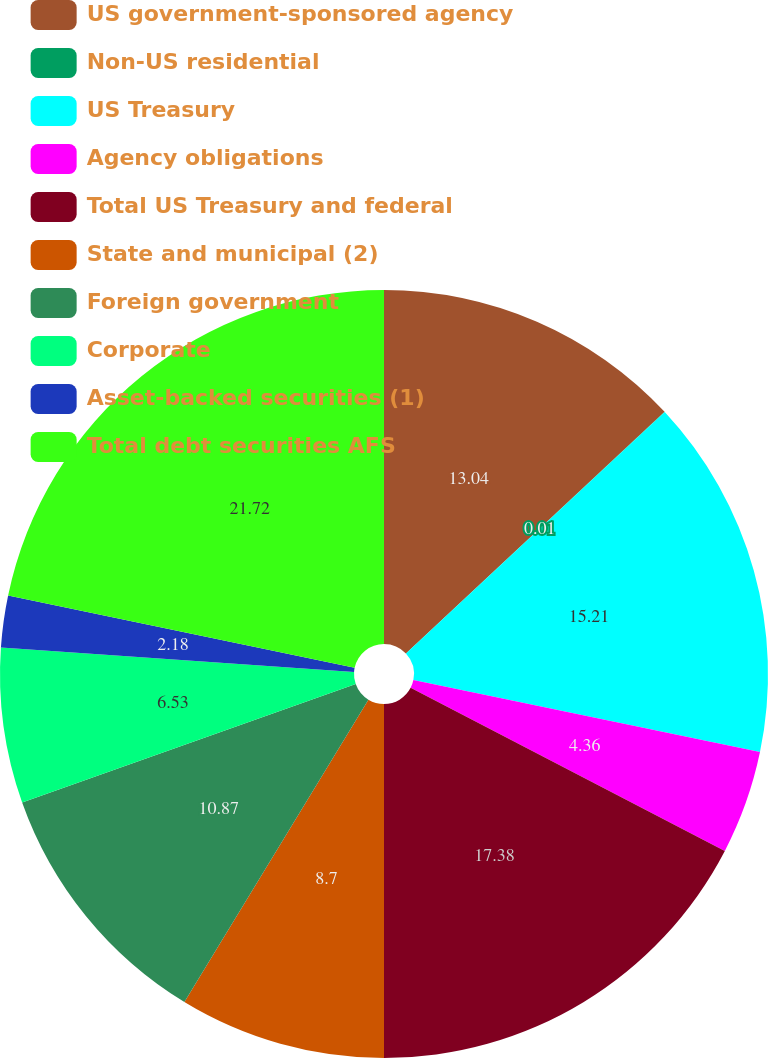Convert chart to OTSL. <chart><loc_0><loc_0><loc_500><loc_500><pie_chart><fcel>US government-sponsored agency<fcel>Non-US residential<fcel>US Treasury<fcel>Agency obligations<fcel>Total US Treasury and federal<fcel>State and municipal (2)<fcel>Foreign government<fcel>Corporate<fcel>Asset-backed securities (1)<fcel>Total debt securities AFS<nl><fcel>13.04%<fcel>0.01%<fcel>15.21%<fcel>4.36%<fcel>17.38%<fcel>8.7%<fcel>10.87%<fcel>6.53%<fcel>2.18%<fcel>21.72%<nl></chart> 